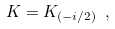Convert formula to latex. <formula><loc_0><loc_0><loc_500><loc_500>K = K _ { ( - i / 2 ) } \ ,</formula> 